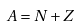<formula> <loc_0><loc_0><loc_500><loc_500>A = N + Z</formula> 